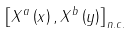<formula> <loc_0><loc_0><loc_500><loc_500>\left [ X ^ { a } \left ( x \right ) , X ^ { b } \left ( y \right ) \right ] _ { n . c . }</formula> 